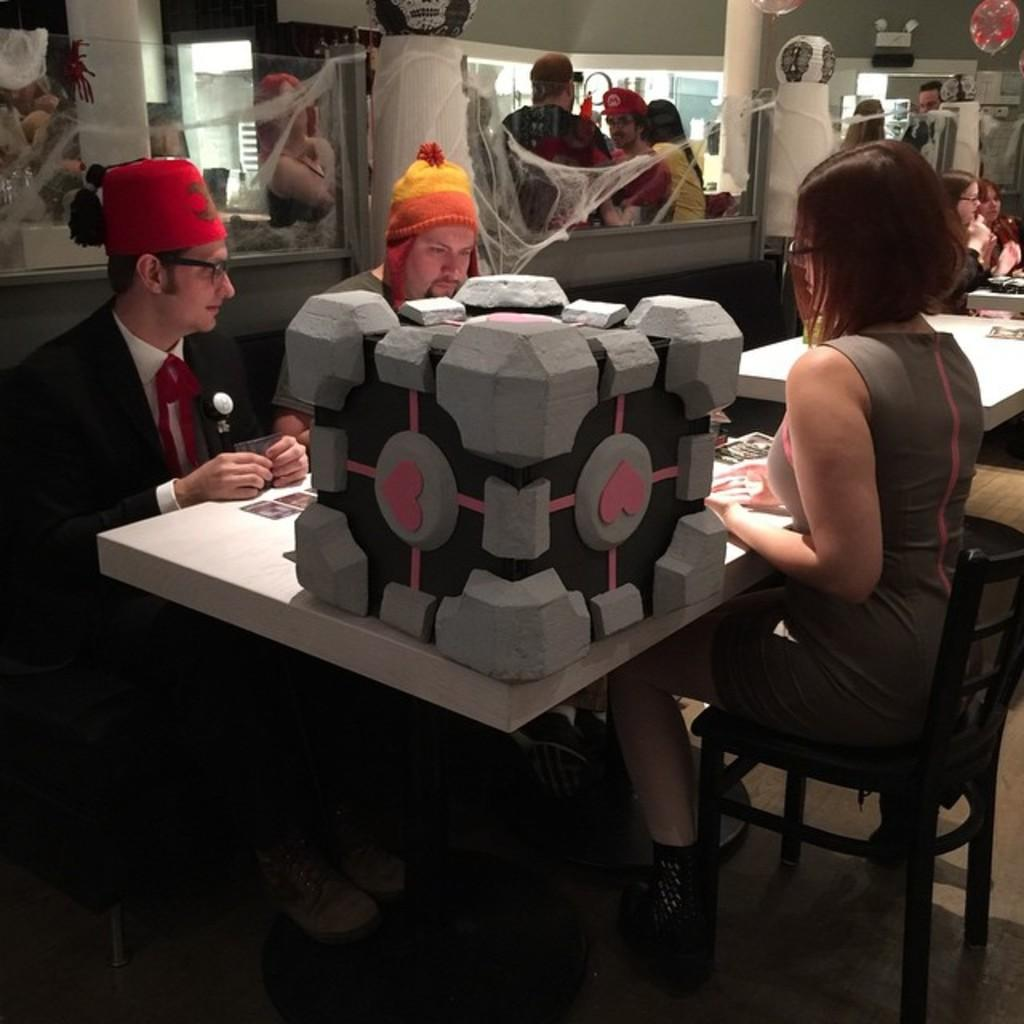How many people are in the image? There is a group of people in the image, but the exact number is not specified. What are some of the people in the image doing? Some people are standing, and some people are sitting on chairs. What can be found on the table in the image? There are objects on the table, but their specific nature is not mentioned. What type of curtain can be seen hanging from the carriage in the image? There is no carriage or curtain present in the image. Can you describe the sea visible in the background of the image? There is no sea visible in the image; it does not feature any outdoor or natural scenery. 